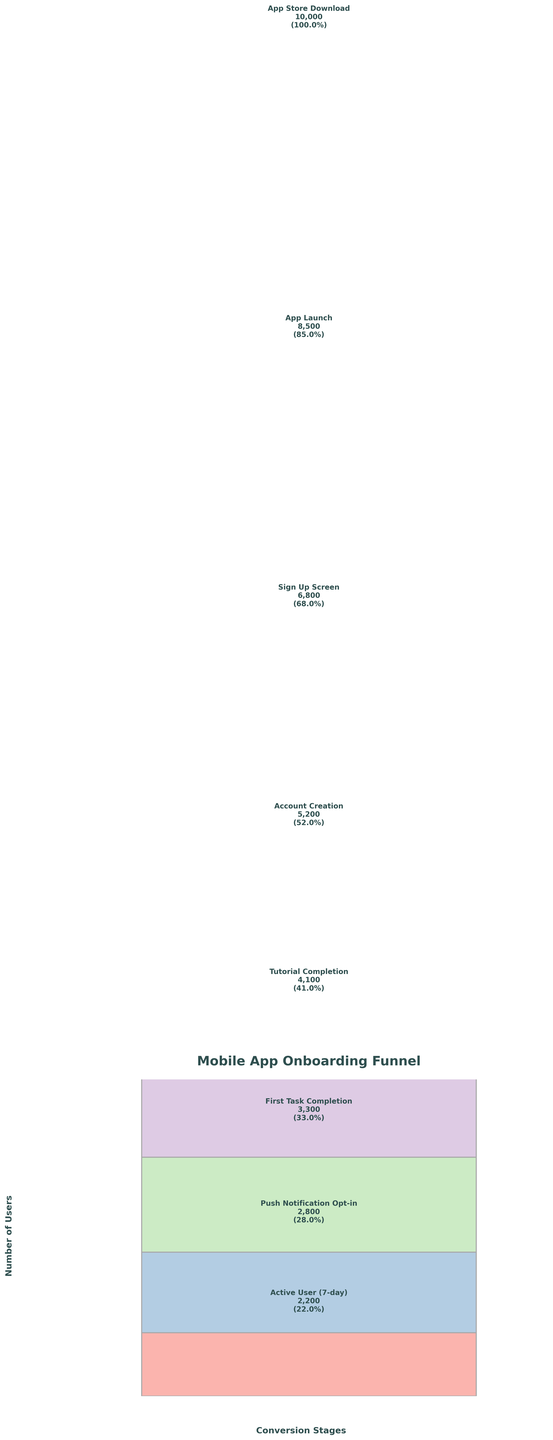What is the title of the funnel chart? The title of the chart is located at the top and is clearly indicated in bold text.
Answer: Mobile App Onboarding Funnel How many users completed the tutorial? The tutorial completion stage is marked on the funnel with a specific user count. This user count is shown as 4,100 users.
Answer: 4,100 At which stage is the largest drop-off in user percentage observed? To determine the largest drop-off, compare the percentages between consecutive stages. The biggest decrease is from the Sign Up Screen (68%) to Account Creation (52%), which is a difference of 16%.
Answer: From Sign Up Screen to Account Creation What is the percentage of users who completed the first task? The funnel chart shows different stages with their respective user counts and percentages. The First Task Completion stage shows 33%.
Answer: 33% How many stages are there in the funnel chart? Count the distinct stages listed in the funnel chart starting from App Store Download to Active User (7-day).
Answer: Eight How many more users signed up at the Sign-Up Screen compared to those who opted for push notifications? The number of users at the Sign-Up Screen is 6,800 and at the Push Notification Opt-in is 2,800. The difference is 6,800 - 2,800.
Answer: 4,000 What is the percentage of active users after 7 days? The final stage of the funnel shows the number of active users after 7 days which is also indicated with a percentage. This is shown as 22%.
Answer: 22% What stage follows Account Creation in the funnel chart? Following the sequence of the stages listed in the funnel, the stage that comes after Account Creation is Tutorial Completion.
Answer: Tutorial Completion Which stage has just over 50% of users reaching it? The chart lists the percentage for each stage. The Account Creation stage has 52% of users, which fits this criterion.
Answer: Account Creation How many users started the app but did not reach the sign-up screen? The number of users who launched the app is 8,500, and those who reached the Sign-Up Screen is 6,800. The difference is 8,500 - 6,800.
Answer: 1,700 